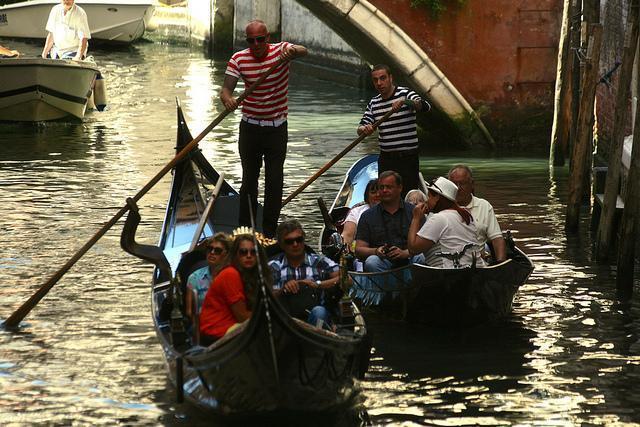How many boats?
Give a very brief answer. 4. How many boats are there?
Give a very brief answer. 5. How many people are there?
Give a very brief answer. 8. How many train cars are in the image?
Give a very brief answer. 0. 